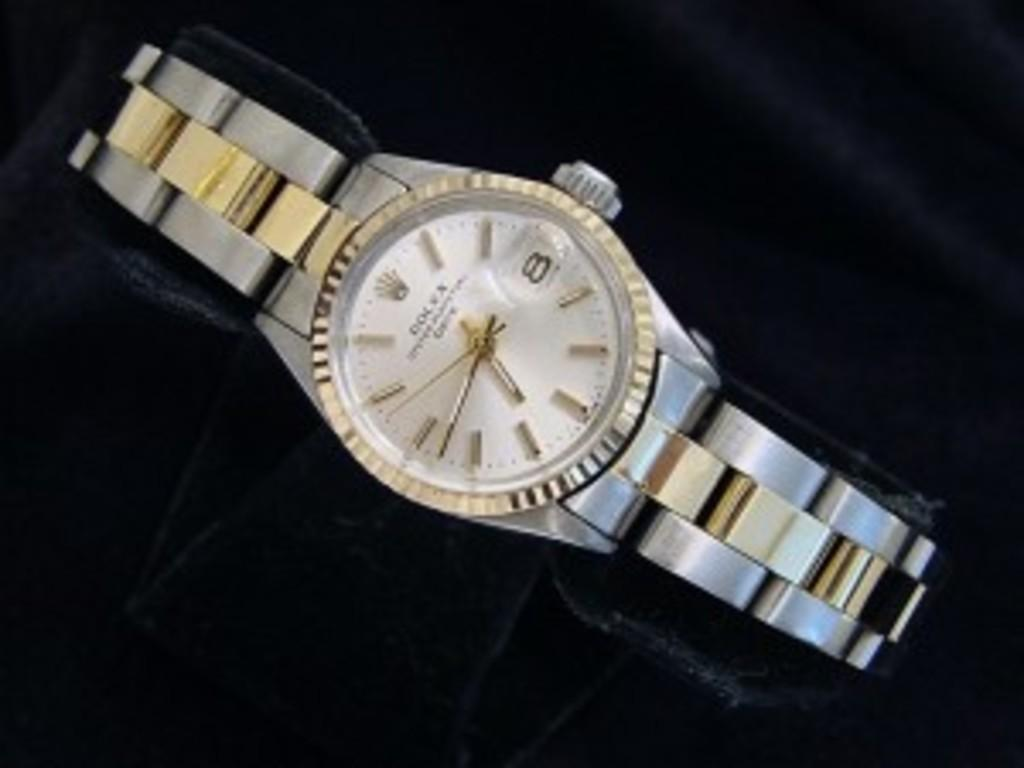Provide a one-sentence caption for the provided image. A gold and silver watch with the digit 8 on the right side. 